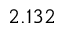<formula> <loc_0><loc_0><loc_500><loc_500>2 . 1 3 2</formula> 